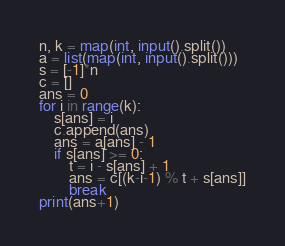<code> <loc_0><loc_0><loc_500><loc_500><_Python_>n, k = map(int, input().split())
a = list(map(int, input().split()))
s = [-1]*n
c = []
ans = 0
for i in range(k):
    s[ans] = i
    c.append(ans)
    ans = a[ans] - 1
    if s[ans] >= 0:
        t = i - s[ans] + 1
        ans = c[(k-i-1) % t + s[ans]]
        break
print(ans+1)</code> 